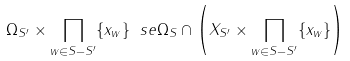<formula> <loc_0><loc_0><loc_500><loc_500>\Omega _ { S ^ { \prime } } \times \prod _ { w \in S - S ^ { \prime } } \{ x _ { w } \} \ s e \Omega _ { S } \cap \left ( X _ { S ^ { \prime } } \times \prod _ { w \in S - S ^ { \prime } } \{ x _ { w } \} \right )</formula> 